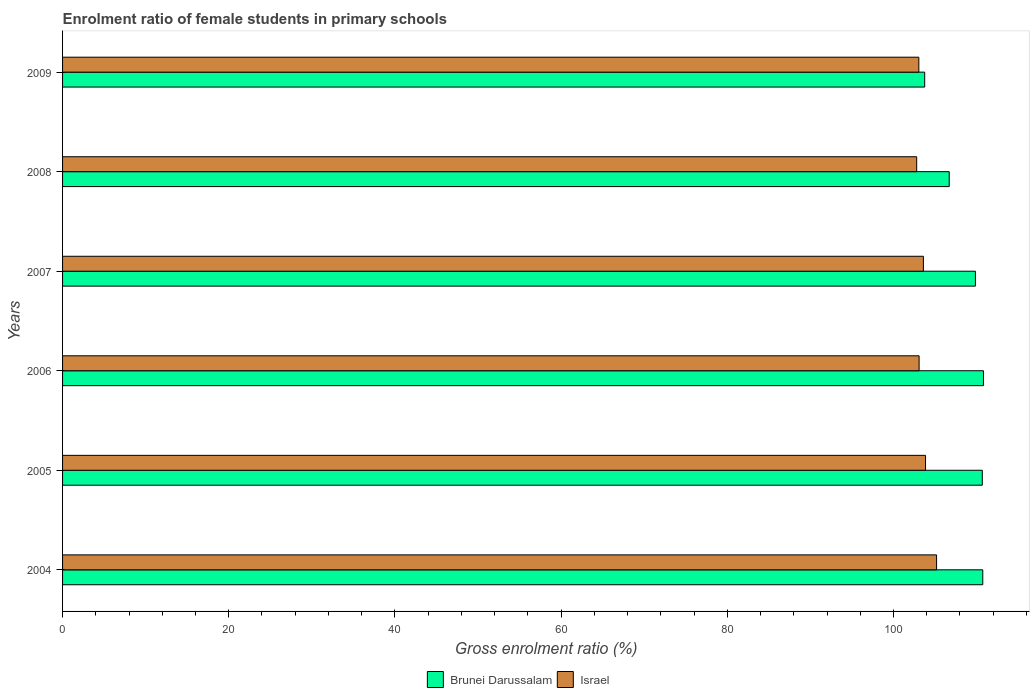How many groups of bars are there?
Your answer should be very brief. 6. Are the number of bars per tick equal to the number of legend labels?
Your answer should be very brief. Yes. How many bars are there on the 6th tick from the top?
Provide a short and direct response. 2. How many bars are there on the 5th tick from the bottom?
Ensure brevity in your answer.  2. What is the label of the 1st group of bars from the top?
Make the answer very short. 2009. In how many cases, is the number of bars for a given year not equal to the number of legend labels?
Make the answer very short. 0. What is the enrolment ratio of female students in primary schools in Israel in 2009?
Your response must be concise. 103.05. Across all years, what is the maximum enrolment ratio of female students in primary schools in Brunei Darussalam?
Ensure brevity in your answer.  110.83. Across all years, what is the minimum enrolment ratio of female students in primary schools in Brunei Darussalam?
Your response must be concise. 103.76. What is the total enrolment ratio of female students in primary schools in Israel in the graph?
Ensure brevity in your answer.  621.56. What is the difference between the enrolment ratio of female students in primary schools in Brunei Darussalam in 2005 and that in 2009?
Ensure brevity in your answer.  6.93. What is the difference between the enrolment ratio of female students in primary schools in Brunei Darussalam in 2005 and the enrolment ratio of female students in primary schools in Israel in 2007?
Provide a succinct answer. 7.09. What is the average enrolment ratio of female students in primary schools in Israel per year?
Make the answer very short. 103.59. In the year 2005, what is the difference between the enrolment ratio of female students in primary schools in Brunei Darussalam and enrolment ratio of female students in primary schools in Israel?
Offer a terse response. 6.83. In how many years, is the enrolment ratio of female students in primary schools in Israel greater than 48 %?
Ensure brevity in your answer.  6. What is the ratio of the enrolment ratio of female students in primary schools in Israel in 2004 to that in 2009?
Provide a short and direct response. 1.02. Is the difference between the enrolment ratio of female students in primary schools in Brunei Darussalam in 2004 and 2006 greater than the difference between the enrolment ratio of female students in primary schools in Israel in 2004 and 2006?
Keep it short and to the point. No. What is the difference between the highest and the second highest enrolment ratio of female students in primary schools in Israel?
Provide a short and direct response. 1.33. What is the difference between the highest and the lowest enrolment ratio of female students in primary schools in Brunei Darussalam?
Ensure brevity in your answer.  7.07. What does the 2nd bar from the top in 2004 represents?
Ensure brevity in your answer.  Brunei Darussalam. What does the 2nd bar from the bottom in 2005 represents?
Ensure brevity in your answer.  Israel. Are all the bars in the graph horizontal?
Your answer should be compact. Yes. Where does the legend appear in the graph?
Offer a very short reply. Bottom center. How are the legend labels stacked?
Provide a succinct answer. Horizontal. What is the title of the graph?
Your response must be concise. Enrolment ratio of female students in primary schools. What is the Gross enrolment ratio (%) of Brunei Darussalam in 2004?
Your response must be concise. 110.75. What is the Gross enrolment ratio (%) of Israel in 2004?
Give a very brief answer. 105.18. What is the Gross enrolment ratio (%) of Brunei Darussalam in 2005?
Your response must be concise. 110.69. What is the Gross enrolment ratio (%) of Israel in 2005?
Make the answer very short. 103.86. What is the Gross enrolment ratio (%) of Brunei Darussalam in 2006?
Ensure brevity in your answer.  110.83. What is the Gross enrolment ratio (%) of Israel in 2006?
Your answer should be very brief. 103.08. What is the Gross enrolment ratio (%) in Brunei Darussalam in 2007?
Ensure brevity in your answer.  109.86. What is the Gross enrolment ratio (%) of Israel in 2007?
Offer a very short reply. 103.6. What is the Gross enrolment ratio (%) in Brunei Darussalam in 2008?
Offer a very short reply. 106.71. What is the Gross enrolment ratio (%) of Israel in 2008?
Provide a short and direct response. 102.79. What is the Gross enrolment ratio (%) in Brunei Darussalam in 2009?
Provide a succinct answer. 103.76. What is the Gross enrolment ratio (%) of Israel in 2009?
Make the answer very short. 103.05. Across all years, what is the maximum Gross enrolment ratio (%) in Brunei Darussalam?
Offer a terse response. 110.83. Across all years, what is the maximum Gross enrolment ratio (%) in Israel?
Keep it short and to the point. 105.18. Across all years, what is the minimum Gross enrolment ratio (%) in Brunei Darussalam?
Provide a succinct answer. 103.76. Across all years, what is the minimum Gross enrolment ratio (%) of Israel?
Keep it short and to the point. 102.79. What is the total Gross enrolment ratio (%) of Brunei Darussalam in the graph?
Make the answer very short. 652.58. What is the total Gross enrolment ratio (%) of Israel in the graph?
Offer a very short reply. 621.56. What is the difference between the Gross enrolment ratio (%) in Brunei Darussalam in 2004 and that in 2005?
Offer a very short reply. 0.06. What is the difference between the Gross enrolment ratio (%) of Israel in 2004 and that in 2005?
Offer a terse response. 1.33. What is the difference between the Gross enrolment ratio (%) in Brunei Darussalam in 2004 and that in 2006?
Your response must be concise. -0.08. What is the difference between the Gross enrolment ratio (%) of Israel in 2004 and that in 2006?
Make the answer very short. 2.1. What is the difference between the Gross enrolment ratio (%) of Brunei Darussalam in 2004 and that in 2007?
Keep it short and to the point. 0.89. What is the difference between the Gross enrolment ratio (%) of Israel in 2004 and that in 2007?
Give a very brief answer. 1.58. What is the difference between the Gross enrolment ratio (%) of Brunei Darussalam in 2004 and that in 2008?
Your answer should be very brief. 4.04. What is the difference between the Gross enrolment ratio (%) of Israel in 2004 and that in 2008?
Make the answer very short. 2.39. What is the difference between the Gross enrolment ratio (%) of Brunei Darussalam in 2004 and that in 2009?
Give a very brief answer. 6.99. What is the difference between the Gross enrolment ratio (%) in Israel in 2004 and that in 2009?
Make the answer very short. 2.14. What is the difference between the Gross enrolment ratio (%) of Brunei Darussalam in 2005 and that in 2006?
Offer a very short reply. -0.14. What is the difference between the Gross enrolment ratio (%) in Israel in 2005 and that in 2006?
Offer a terse response. 0.77. What is the difference between the Gross enrolment ratio (%) in Brunei Darussalam in 2005 and that in 2007?
Keep it short and to the point. 0.83. What is the difference between the Gross enrolment ratio (%) of Israel in 2005 and that in 2007?
Ensure brevity in your answer.  0.26. What is the difference between the Gross enrolment ratio (%) in Brunei Darussalam in 2005 and that in 2008?
Keep it short and to the point. 3.98. What is the difference between the Gross enrolment ratio (%) of Israel in 2005 and that in 2008?
Ensure brevity in your answer.  1.06. What is the difference between the Gross enrolment ratio (%) of Brunei Darussalam in 2005 and that in 2009?
Keep it short and to the point. 6.93. What is the difference between the Gross enrolment ratio (%) in Israel in 2005 and that in 2009?
Give a very brief answer. 0.81. What is the difference between the Gross enrolment ratio (%) of Brunei Darussalam in 2006 and that in 2007?
Keep it short and to the point. 0.97. What is the difference between the Gross enrolment ratio (%) in Israel in 2006 and that in 2007?
Your response must be concise. -0.52. What is the difference between the Gross enrolment ratio (%) in Brunei Darussalam in 2006 and that in 2008?
Ensure brevity in your answer.  4.12. What is the difference between the Gross enrolment ratio (%) in Israel in 2006 and that in 2008?
Ensure brevity in your answer.  0.29. What is the difference between the Gross enrolment ratio (%) of Brunei Darussalam in 2006 and that in 2009?
Your response must be concise. 7.07. What is the difference between the Gross enrolment ratio (%) in Israel in 2006 and that in 2009?
Provide a short and direct response. 0.03. What is the difference between the Gross enrolment ratio (%) in Brunei Darussalam in 2007 and that in 2008?
Your response must be concise. 3.15. What is the difference between the Gross enrolment ratio (%) in Israel in 2007 and that in 2008?
Your answer should be very brief. 0.81. What is the difference between the Gross enrolment ratio (%) in Brunei Darussalam in 2007 and that in 2009?
Give a very brief answer. 6.1. What is the difference between the Gross enrolment ratio (%) of Israel in 2007 and that in 2009?
Ensure brevity in your answer.  0.55. What is the difference between the Gross enrolment ratio (%) of Brunei Darussalam in 2008 and that in 2009?
Offer a very short reply. 2.95. What is the difference between the Gross enrolment ratio (%) in Israel in 2008 and that in 2009?
Make the answer very short. -0.26. What is the difference between the Gross enrolment ratio (%) in Brunei Darussalam in 2004 and the Gross enrolment ratio (%) in Israel in 2005?
Keep it short and to the point. 6.89. What is the difference between the Gross enrolment ratio (%) of Brunei Darussalam in 2004 and the Gross enrolment ratio (%) of Israel in 2006?
Your answer should be compact. 7.66. What is the difference between the Gross enrolment ratio (%) of Brunei Darussalam in 2004 and the Gross enrolment ratio (%) of Israel in 2007?
Your answer should be compact. 7.15. What is the difference between the Gross enrolment ratio (%) of Brunei Darussalam in 2004 and the Gross enrolment ratio (%) of Israel in 2008?
Your response must be concise. 7.95. What is the difference between the Gross enrolment ratio (%) of Brunei Darussalam in 2004 and the Gross enrolment ratio (%) of Israel in 2009?
Your answer should be compact. 7.7. What is the difference between the Gross enrolment ratio (%) of Brunei Darussalam in 2005 and the Gross enrolment ratio (%) of Israel in 2006?
Your answer should be compact. 7.61. What is the difference between the Gross enrolment ratio (%) in Brunei Darussalam in 2005 and the Gross enrolment ratio (%) in Israel in 2007?
Provide a succinct answer. 7.09. What is the difference between the Gross enrolment ratio (%) in Brunei Darussalam in 2005 and the Gross enrolment ratio (%) in Israel in 2008?
Provide a succinct answer. 7.9. What is the difference between the Gross enrolment ratio (%) in Brunei Darussalam in 2005 and the Gross enrolment ratio (%) in Israel in 2009?
Offer a terse response. 7.64. What is the difference between the Gross enrolment ratio (%) in Brunei Darussalam in 2006 and the Gross enrolment ratio (%) in Israel in 2007?
Ensure brevity in your answer.  7.23. What is the difference between the Gross enrolment ratio (%) of Brunei Darussalam in 2006 and the Gross enrolment ratio (%) of Israel in 2008?
Your answer should be very brief. 8.03. What is the difference between the Gross enrolment ratio (%) in Brunei Darussalam in 2006 and the Gross enrolment ratio (%) in Israel in 2009?
Your answer should be very brief. 7.78. What is the difference between the Gross enrolment ratio (%) of Brunei Darussalam in 2007 and the Gross enrolment ratio (%) of Israel in 2008?
Offer a terse response. 7.07. What is the difference between the Gross enrolment ratio (%) of Brunei Darussalam in 2007 and the Gross enrolment ratio (%) of Israel in 2009?
Provide a short and direct response. 6.81. What is the difference between the Gross enrolment ratio (%) of Brunei Darussalam in 2008 and the Gross enrolment ratio (%) of Israel in 2009?
Offer a very short reply. 3.66. What is the average Gross enrolment ratio (%) in Brunei Darussalam per year?
Your answer should be very brief. 108.76. What is the average Gross enrolment ratio (%) of Israel per year?
Offer a terse response. 103.59. In the year 2004, what is the difference between the Gross enrolment ratio (%) in Brunei Darussalam and Gross enrolment ratio (%) in Israel?
Give a very brief answer. 5.56. In the year 2005, what is the difference between the Gross enrolment ratio (%) of Brunei Darussalam and Gross enrolment ratio (%) of Israel?
Provide a succinct answer. 6.83. In the year 2006, what is the difference between the Gross enrolment ratio (%) of Brunei Darussalam and Gross enrolment ratio (%) of Israel?
Ensure brevity in your answer.  7.74. In the year 2007, what is the difference between the Gross enrolment ratio (%) in Brunei Darussalam and Gross enrolment ratio (%) in Israel?
Ensure brevity in your answer.  6.26. In the year 2008, what is the difference between the Gross enrolment ratio (%) in Brunei Darussalam and Gross enrolment ratio (%) in Israel?
Offer a very short reply. 3.91. In the year 2009, what is the difference between the Gross enrolment ratio (%) of Brunei Darussalam and Gross enrolment ratio (%) of Israel?
Make the answer very short. 0.71. What is the ratio of the Gross enrolment ratio (%) of Brunei Darussalam in 2004 to that in 2005?
Provide a succinct answer. 1. What is the ratio of the Gross enrolment ratio (%) of Israel in 2004 to that in 2005?
Ensure brevity in your answer.  1.01. What is the ratio of the Gross enrolment ratio (%) in Israel in 2004 to that in 2006?
Your response must be concise. 1.02. What is the ratio of the Gross enrolment ratio (%) in Brunei Darussalam in 2004 to that in 2007?
Your answer should be very brief. 1.01. What is the ratio of the Gross enrolment ratio (%) in Israel in 2004 to that in 2007?
Keep it short and to the point. 1.02. What is the ratio of the Gross enrolment ratio (%) in Brunei Darussalam in 2004 to that in 2008?
Keep it short and to the point. 1.04. What is the ratio of the Gross enrolment ratio (%) of Israel in 2004 to that in 2008?
Give a very brief answer. 1.02. What is the ratio of the Gross enrolment ratio (%) in Brunei Darussalam in 2004 to that in 2009?
Keep it short and to the point. 1.07. What is the ratio of the Gross enrolment ratio (%) of Israel in 2004 to that in 2009?
Ensure brevity in your answer.  1.02. What is the ratio of the Gross enrolment ratio (%) in Israel in 2005 to that in 2006?
Your answer should be very brief. 1.01. What is the ratio of the Gross enrolment ratio (%) in Brunei Darussalam in 2005 to that in 2007?
Provide a succinct answer. 1.01. What is the ratio of the Gross enrolment ratio (%) of Israel in 2005 to that in 2007?
Keep it short and to the point. 1. What is the ratio of the Gross enrolment ratio (%) in Brunei Darussalam in 2005 to that in 2008?
Give a very brief answer. 1.04. What is the ratio of the Gross enrolment ratio (%) in Israel in 2005 to that in 2008?
Keep it short and to the point. 1.01. What is the ratio of the Gross enrolment ratio (%) of Brunei Darussalam in 2005 to that in 2009?
Give a very brief answer. 1.07. What is the ratio of the Gross enrolment ratio (%) of Israel in 2005 to that in 2009?
Offer a terse response. 1.01. What is the ratio of the Gross enrolment ratio (%) in Brunei Darussalam in 2006 to that in 2007?
Provide a short and direct response. 1.01. What is the ratio of the Gross enrolment ratio (%) in Brunei Darussalam in 2006 to that in 2008?
Your answer should be compact. 1.04. What is the ratio of the Gross enrolment ratio (%) in Israel in 2006 to that in 2008?
Offer a terse response. 1. What is the ratio of the Gross enrolment ratio (%) in Brunei Darussalam in 2006 to that in 2009?
Your response must be concise. 1.07. What is the ratio of the Gross enrolment ratio (%) in Brunei Darussalam in 2007 to that in 2008?
Your answer should be compact. 1.03. What is the ratio of the Gross enrolment ratio (%) of Israel in 2007 to that in 2008?
Ensure brevity in your answer.  1.01. What is the ratio of the Gross enrolment ratio (%) of Brunei Darussalam in 2007 to that in 2009?
Offer a very short reply. 1.06. What is the ratio of the Gross enrolment ratio (%) in Israel in 2007 to that in 2009?
Your answer should be very brief. 1.01. What is the ratio of the Gross enrolment ratio (%) of Brunei Darussalam in 2008 to that in 2009?
Your answer should be very brief. 1.03. What is the ratio of the Gross enrolment ratio (%) of Israel in 2008 to that in 2009?
Offer a very short reply. 1. What is the difference between the highest and the second highest Gross enrolment ratio (%) in Brunei Darussalam?
Offer a terse response. 0.08. What is the difference between the highest and the second highest Gross enrolment ratio (%) in Israel?
Give a very brief answer. 1.33. What is the difference between the highest and the lowest Gross enrolment ratio (%) in Brunei Darussalam?
Provide a short and direct response. 7.07. What is the difference between the highest and the lowest Gross enrolment ratio (%) in Israel?
Provide a succinct answer. 2.39. 